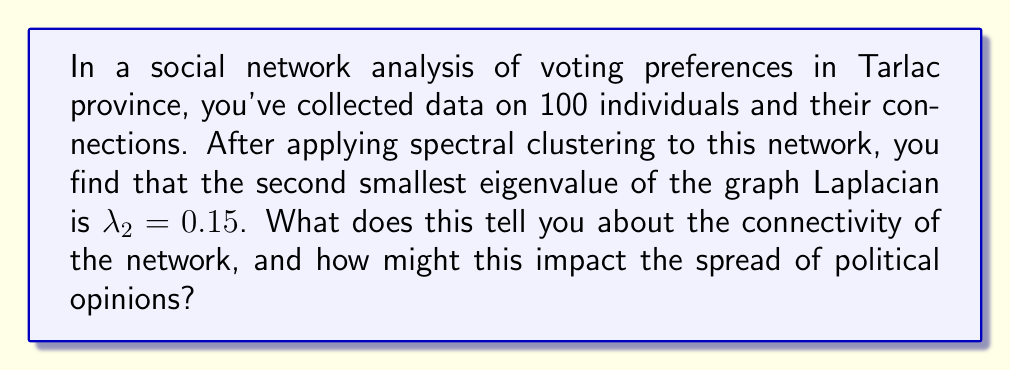Give your solution to this math problem. To understand the significance of $\lambda_2 = 0.15$ in the context of spectral clustering and opinion dynamics, let's break it down step-by-step:

1) The second smallest eigenvalue of the graph Laplacian, $\lambda_2$, is also known as the algebraic connectivity or Fiedler value of the graph.

2) $\lambda_2$ provides information about the overall connectivity of the network:
   - $\lambda_2 = 0$ if and only if the graph is disconnected.
   - Larger values of $\lambda_2$ indicate better connectivity.

3) In this case, $\lambda_2 = 0.15$, which is relatively small but not zero. This suggests:
   - The network is connected (not divided into completely separate components).
   - However, the connectivity is weak, indicating the presence of loosely connected clusters.

4) For opinion dynamics, we can interpret this as follows:
   - The network likely has some natural divisions or communities.
   - These communities might represent groups with similar political views.

5) The impact on opinion spread:
   - Opinions are likely to spread quickly within each community.
   - However, there may be barriers to opinion spread between different communities.

6) In terms of spectral clustering:
   - The small $\lambda_2$ suggests that the network can be effectively divided into clusters.
   - These clusters might represent different political factions or ideological groups in Tarlac.

7) For political science implications:
   - This network structure might lead to polarization of opinions.
   - It could be challenging for a single political message to reach all parts of the network equally.

8) The algebraic connectivity can be related to the mixing time of random walks on the graph:
   $$t_{mix} \approx \frac{1}{\lambda_2}$$
   
   Here, $t_{mix} \approx \frac{1}{0.15} \approx 6.67$, suggesting a relatively slow mixing time.
Answer: Weak connectivity; likely clustered structure; potential for opinion polarization; slow information spread across clusters. 